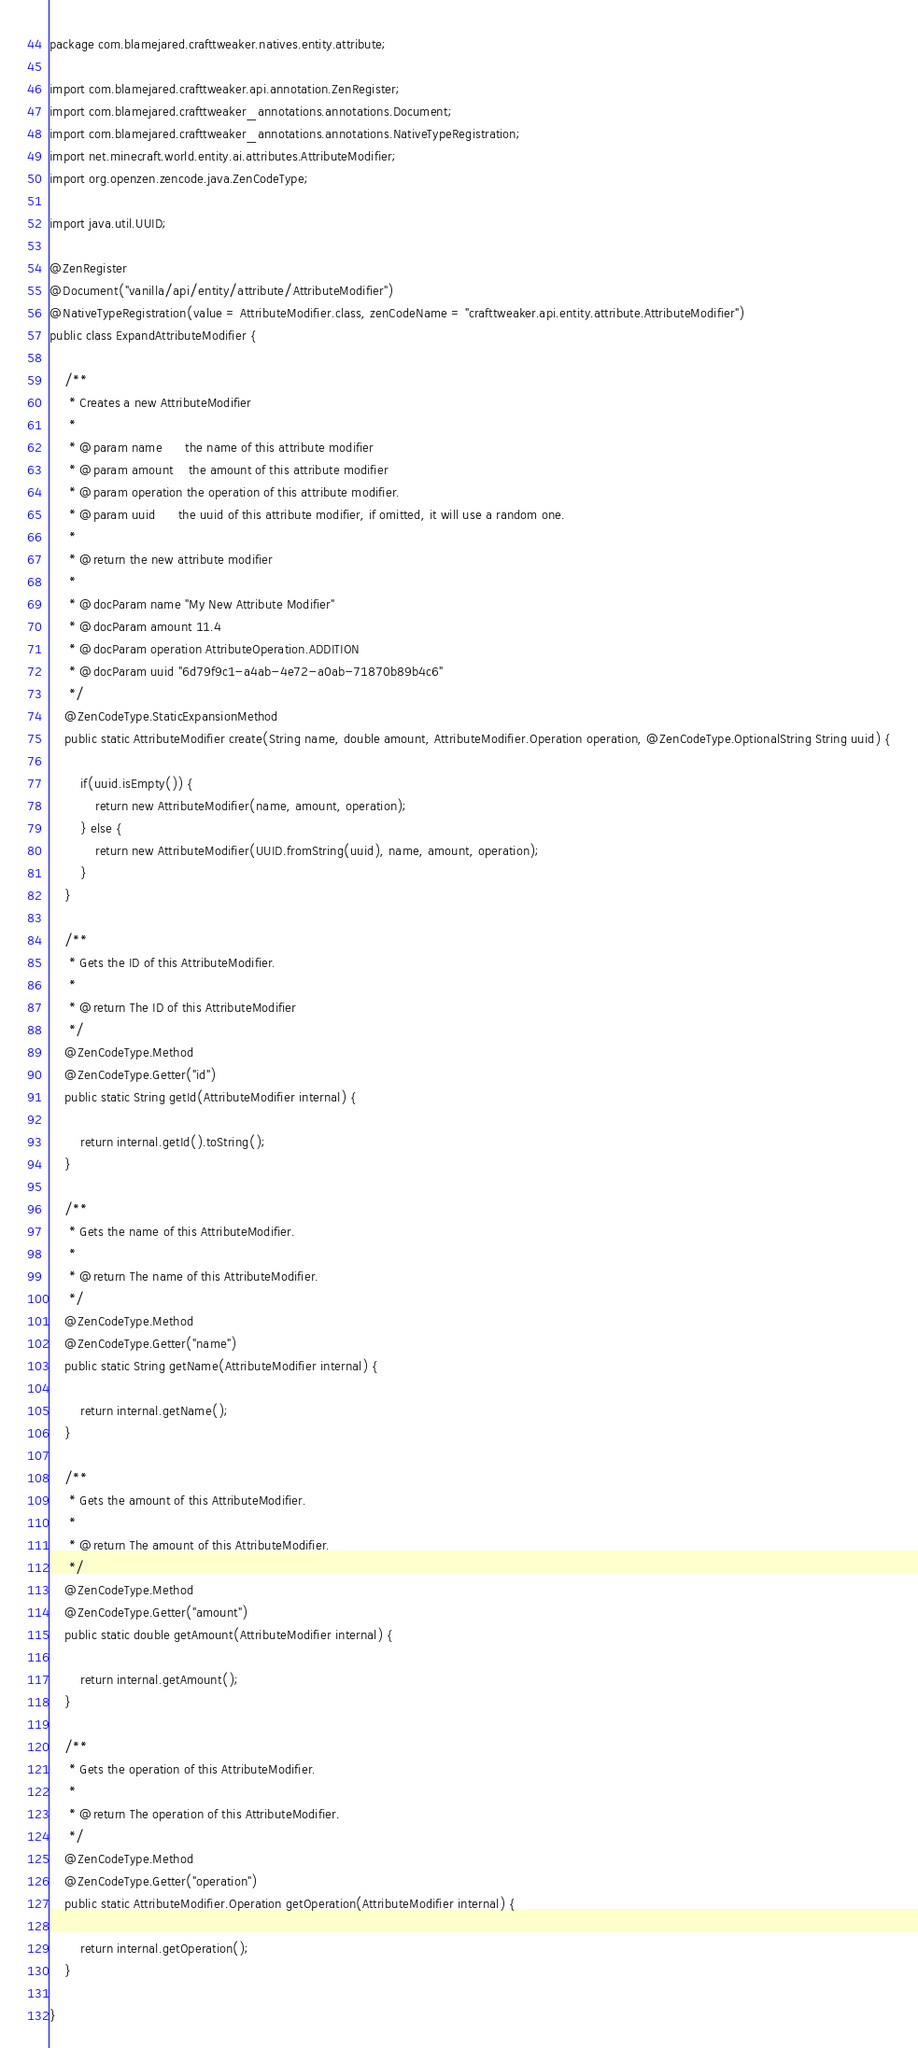<code> <loc_0><loc_0><loc_500><loc_500><_Java_>package com.blamejared.crafttweaker.natives.entity.attribute;

import com.blamejared.crafttweaker.api.annotation.ZenRegister;
import com.blamejared.crafttweaker_annotations.annotations.Document;
import com.blamejared.crafttweaker_annotations.annotations.NativeTypeRegistration;
import net.minecraft.world.entity.ai.attributes.AttributeModifier;
import org.openzen.zencode.java.ZenCodeType;

import java.util.UUID;

@ZenRegister
@Document("vanilla/api/entity/attribute/AttributeModifier")
@NativeTypeRegistration(value = AttributeModifier.class, zenCodeName = "crafttweaker.api.entity.attribute.AttributeModifier")
public class ExpandAttributeModifier {
    
    /**
     * Creates a new AttributeModifier
     *
     * @param name      the name of this attribute modifier
     * @param amount    the amount of this attribute modifier
     * @param operation the operation of this attribute modifier.
     * @param uuid      the uuid of this attribute modifier, if omitted, it will use a random one.
     *
     * @return the new attribute modifier
     *
     * @docParam name "My New Attribute Modifier"
     * @docParam amount 11.4
     * @docParam operation AttributeOperation.ADDITION
     * @docParam uuid "6d79f9c1-a4ab-4e72-a0ab-71870b89b4c6"
     */
    @ZenCodeType.StaticExpansionMethod
    public static AttributeModifier create(String name, double amount, AttributeModifier.Operation operation, @ZenCodeType.OptionalString String uuid) {
        
        if(uuid.isEmpty()) {
            return new AttributeModifier(name, amount, operation);
        } else {
            return new AttributeModifier(UUID.fromString(uuid), name, amount, operation);
        }
    }
    
    /**
     * Gets the ID of this AttributeModifier.
     *
     * @return The ID of this AttributeModifier
     */
    @ZenCodeType.Method
    @ZenCodeType.Getter("id")
    public static String getId(AttributeModifier internal) {
        
        return internal.getId().toString();
    }
    
    /**
     * Gets the name of this AttributeModifier.
     *
     * @return The name of this AttributeModifier.
     */
    @ZenCodeType.Method
    @ZenCodeType.Getter("name")
    public static String getName(AttributeModifier internal) {
        
        return internal.getName();
    }
    
    /**
     * Gets the amount of this AttributeModifier.
     *
     * @return The amount of this AttributeModifier.
     */
    @ZenCodeType.Method
    @ZenCodeType.Getter("amount")
    public static double getAmount(AttributeModifier internal) {
        
        return internal.getAmount();
    }
    
    /**
     * Gets the operation of this AttributeModifier.
     *
     * @return The operation of this AttributeModifier.
     */
    @ZenCodeType.Method
    @ZenCodeType.Getter("operation")
    public static AttributeModifier.Operation getOperation(AttributeModifier internal) {
        
        return internal.getOperation();
    }
    
}
</code> 